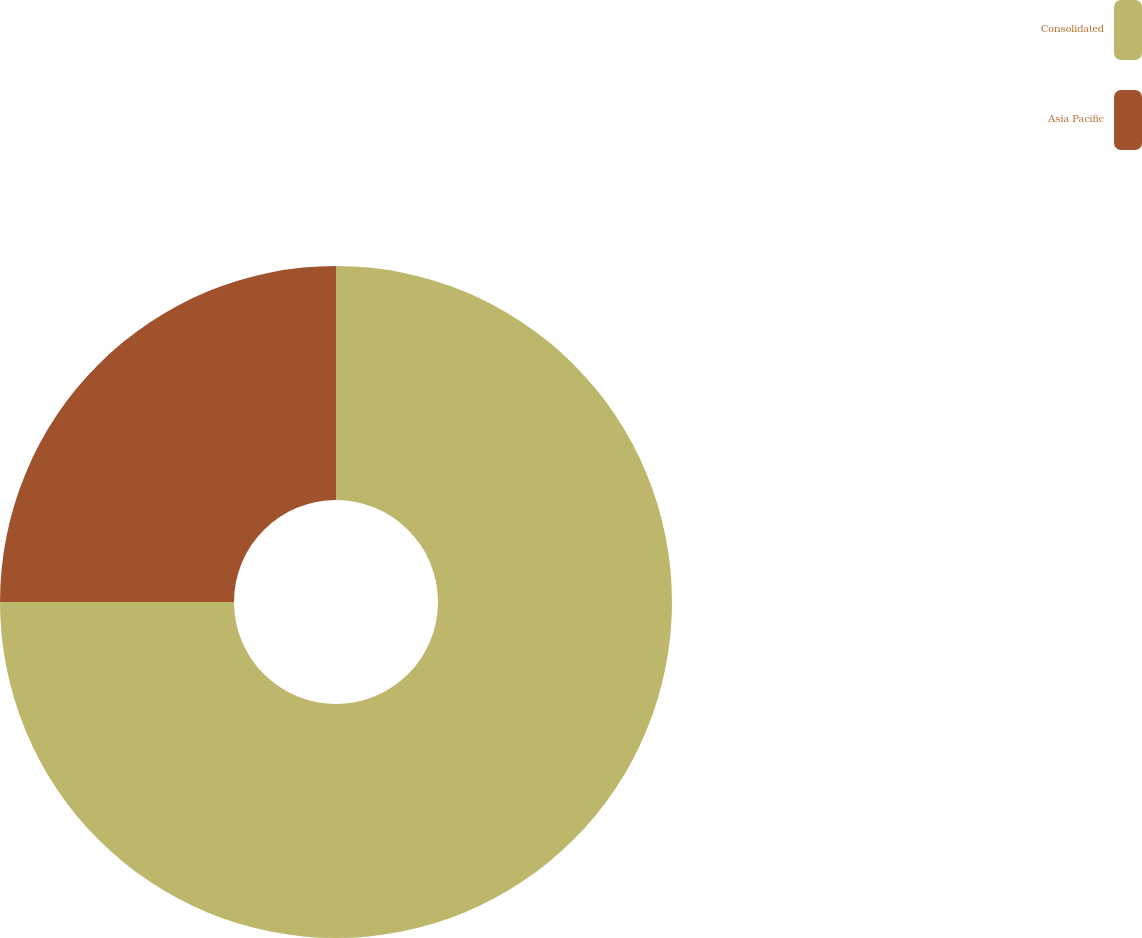Convert chart. <chart><loc_0><loc_0><loc_500><loc_500><pie_chart><fcel>Consolidated<fcel>Asia Pacific<nl><fcel>75.0%<fcel>25.0%<nl></chart> 